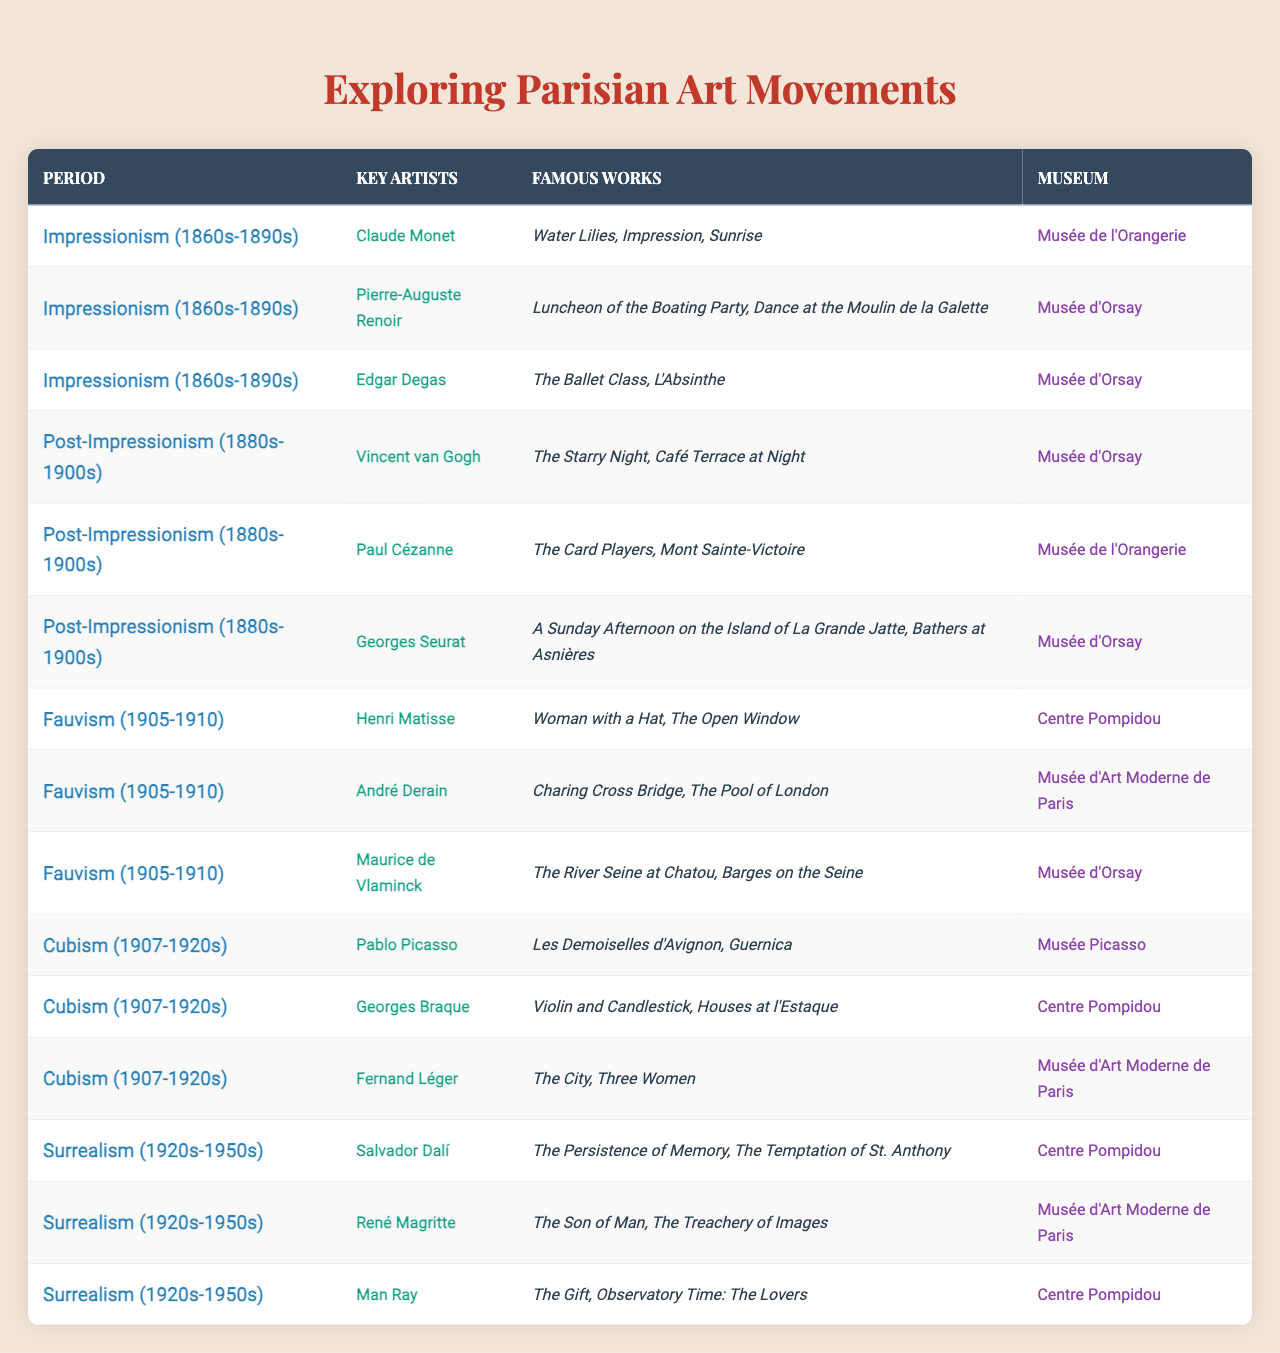What period featured Claude Monet as a key artist? By examining the table, Claude Monet is listed under the section "Impressionism (1860s-1890s)."
Answer: Impressionism (1860s-1890s) Which museum houses Vincent van Gogh's works? Looking at the table, it states that Vincent van Gogh's famous works are at the "Musée d'Orsay."
Answer: Musée d'Orsay Did any artist in the Fauvism movement create works displayed at the Centre Pompidou? The table confirms that Henri Matisse, an artist in the Fauvism movement, has works displayed at the Centre Pompidou.
Answer: Yes How many key artists are associated with the Cubism movement? The table indicates that there are three key artists listed for the Cubism movement: Pablo Picasso, Georges Braque, and Fernand Léger.
Answer: 3 Which artist is known for "A Sunday Afternoon on the Island of La Grande Jatte"? The table shows that Georges Seurat is the artist known for that work, listed under the Post-Impressionism period.
Answer: Georges Seurat Which museum features the most artists among the movements listed? By counting the number of distinct artists' museums, Musée d'Orsay appears multiple times across different periods, indicating it features the most artists.
Answer: Musée d'Orsay What are the famous works of Henri Matisse? The table specifically lists Henri Matisse's famous works as "Woman with a Hat" and "The Open Window."
Answer: Woman with a Hat, The Open Window In which art movement did the artist Fernand Léger participate? The table indicates that Fernand Léger is associated with the Cubism movement.
Answer: Cubism Is the artwork "Guernica" associated with the Surrealism movement? The table shows "Guernica" is created by Pablo Picasso, who is listed under the Cubism movement, not Surrealism, thus the statement is false.
Answer: No What is the total number of artists displayed at the Musée d'Art Moderne de Paris? Counting from the table, there are three artists listed: André Derain, René Magritte, and Fernand Léger, indicating the total is three.
Answer: 3 Which two artists were active during the same period of Impressionism? The table shows Claude Monet and Pierre-Auguste Renoir both associated with the Impressionism period.
Answer: Claude Monet, Pierre-Auguste Renoir How many famous works are attributed to the artist Salvador Dalí? The table states Salvador Dalí is known for two famous works: "The Persistence of Memory" and "The Temptation of St. Anthony."
Answer: 2 Which period showcases the fewest key artists? By analyzing the table, all movements have three artists except for Fauvism with three too; hence, there is no clear "fewest." However, checking further shows that none have fewer than three.
Answer: All have three 